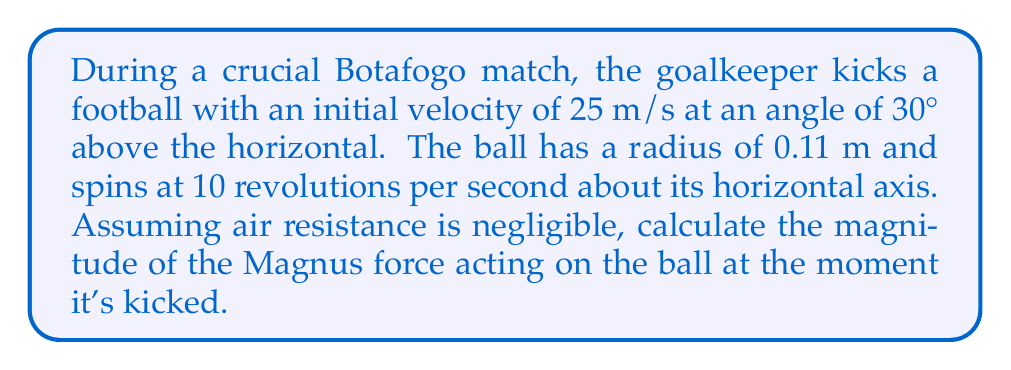Could you help me with this problem? To solve this problem, we'll use the Magnus effect equation and follow these steps:

1) The Magnus force is given by:
   $$F_M = \frac{1}{2} C_L \rho A v^2$$
   where:
   $C_L$ is the lift coefficient
   $\rho$ is the air density
   $A$ is the cross-sectional area of the ball
   $v$ is the velocity of the ball

2) We need to calculate the lift coefficient $C_L$:
   $$C_L = \frac{\pi r \omega}{v}$$
   where:
   $r$ is the radius of the ball
   $\omega$ is the angular velocity

3) Convert angular velocity from revolutions per second to radians per second:
   $$\omega = 2\pi \cdot 10 = 20\pi \text{ rad/s}$$

4) Calculate $C_L$:
   $$C_L = \frac{\pi \cdot 0.11 \cdot 20\pi}{25} = 0.2763$$

5) Calculate the cross-sectional area of the ball:
   $$A = \pi r^2 = \pi \cdot (0.11)^2 = 0.0380 \text{ m}^2$$

6) Use the standard air density at sea level:
   $$\rho = 1.225 \text{ kg/m}^3$$

7) Now we can calculate the Magnus force:
   $$F_M = \frac{1}{2} \cdot 0.2763 \cdot 1.225 \cdot 0.0380 \cdot 25^2 = 2.60 \text{ N}$$
Answer: 2.60 N 